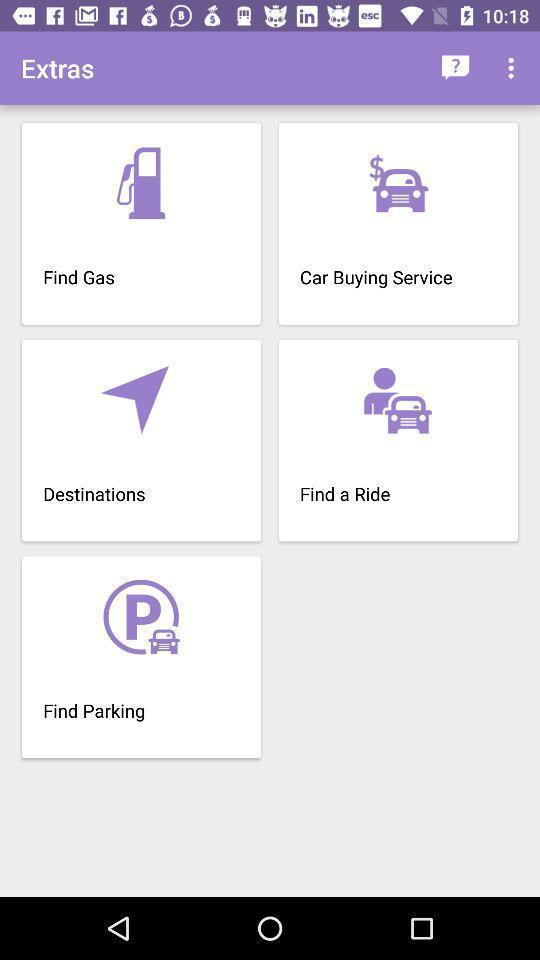Please provide a description for this image. Page showing variety of services. 